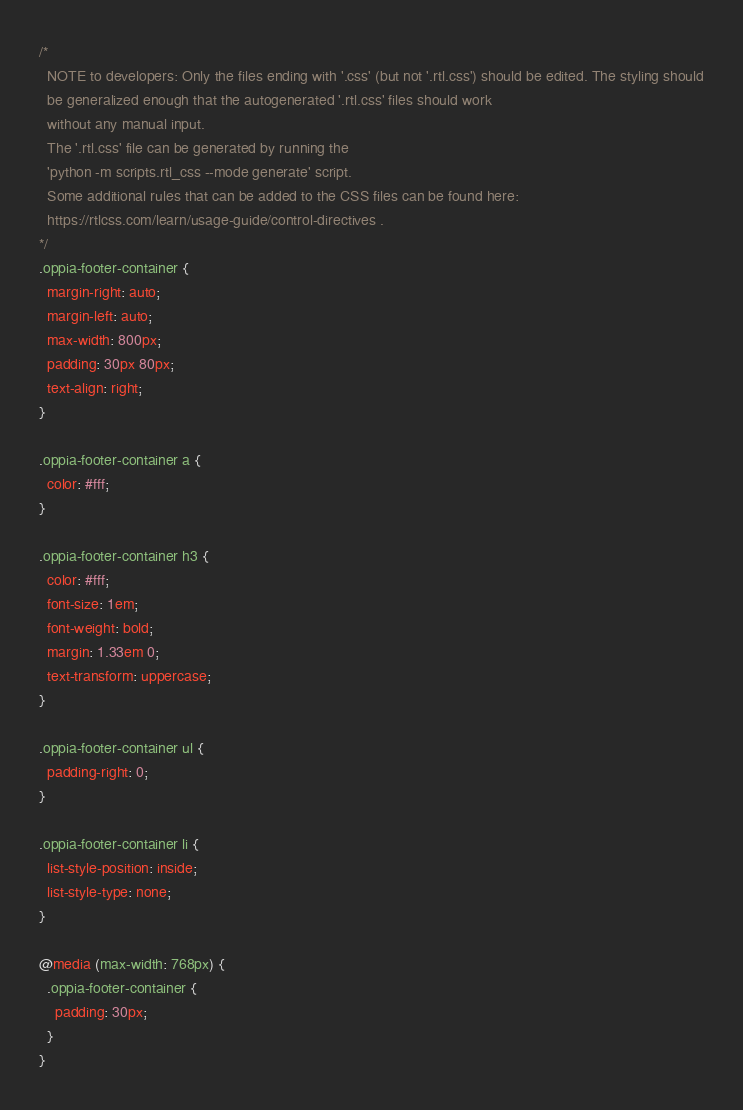<code> <loc_0><loc_0><loc_500><loc_500><_CSS_>/*
  NOTE to developers: Only the files ending with '.css' (but not '.rtl.css') should be edited. The styling should
  be generalized enough that the autogenerated '.rtl.css' files should work
  without any manual input.
  The '.rtl.css' file can be generated by running the
  'python -m scripts.rtl_css --mode generate' script.
  Some additional rules that can be added to the CSS files can be found here:
  https://rtlcss.com/learn/usage-guide/control-directives .
*/
.oppia-footer-container {
  margin-right: auto;
  margin-left: auto;
  max-width: 800px;
  padding: 30px 80px;
  text-align: right;
}

.oppia-footer-container a {
  color: #fff;
}

.oppia-footer-container h3 {
  color: #fff;
  font-size: 1em;
  font-weight: bold;
  margin: 1.33em 0;
  text-transform: uppercase;
}

.oppia-footer-container ul {
  padding-right: 0;
}

.oppia-footer-container li {
  list-style-position: inside;
  list-style-type: none;
}

@media (max-width: 768px) {
  .oppia-footer-container {
    padding: 30px;
  }
}
</code> 